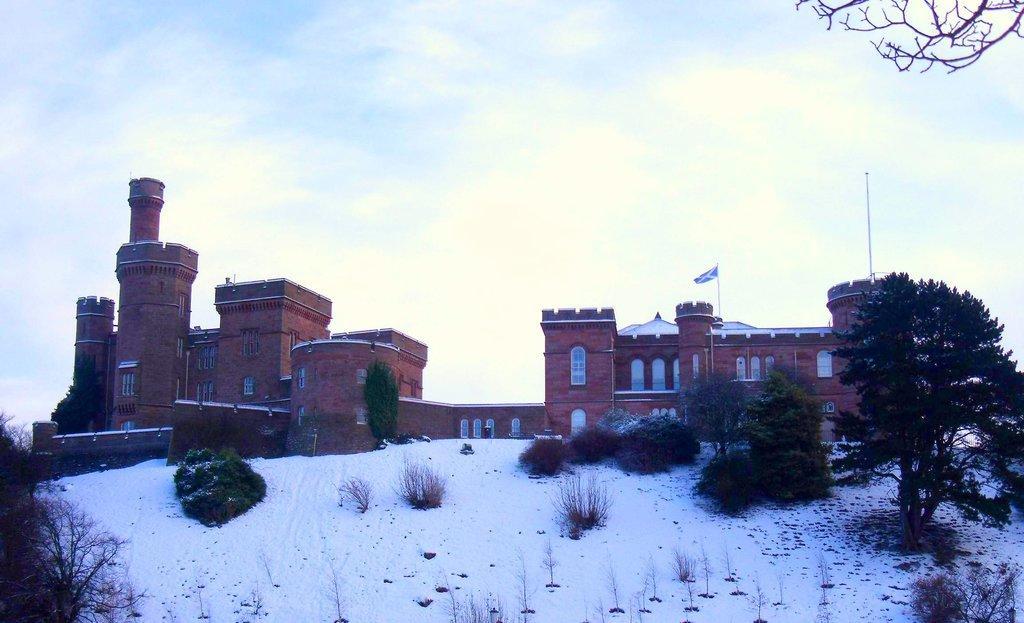Could you give a brief overview of what you see in this image? In this image I can see building which is in brown color, at right I can see flag, trees in green color, snow in white color and sky in blue and white color. 